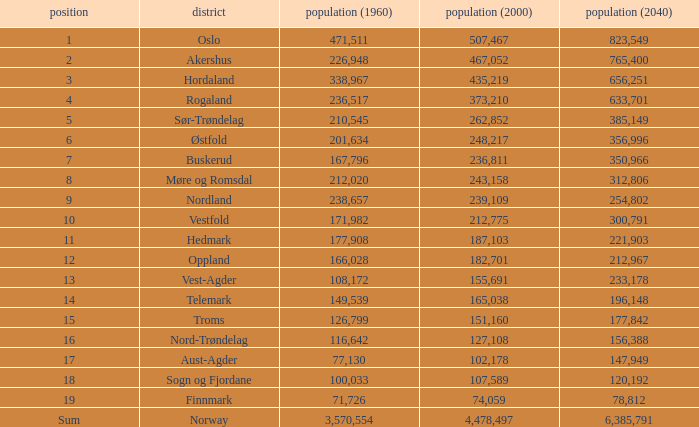What was the population of a county in 1960 that had a population of 467,052 in 2000 and 78,812 in 2040? None. 